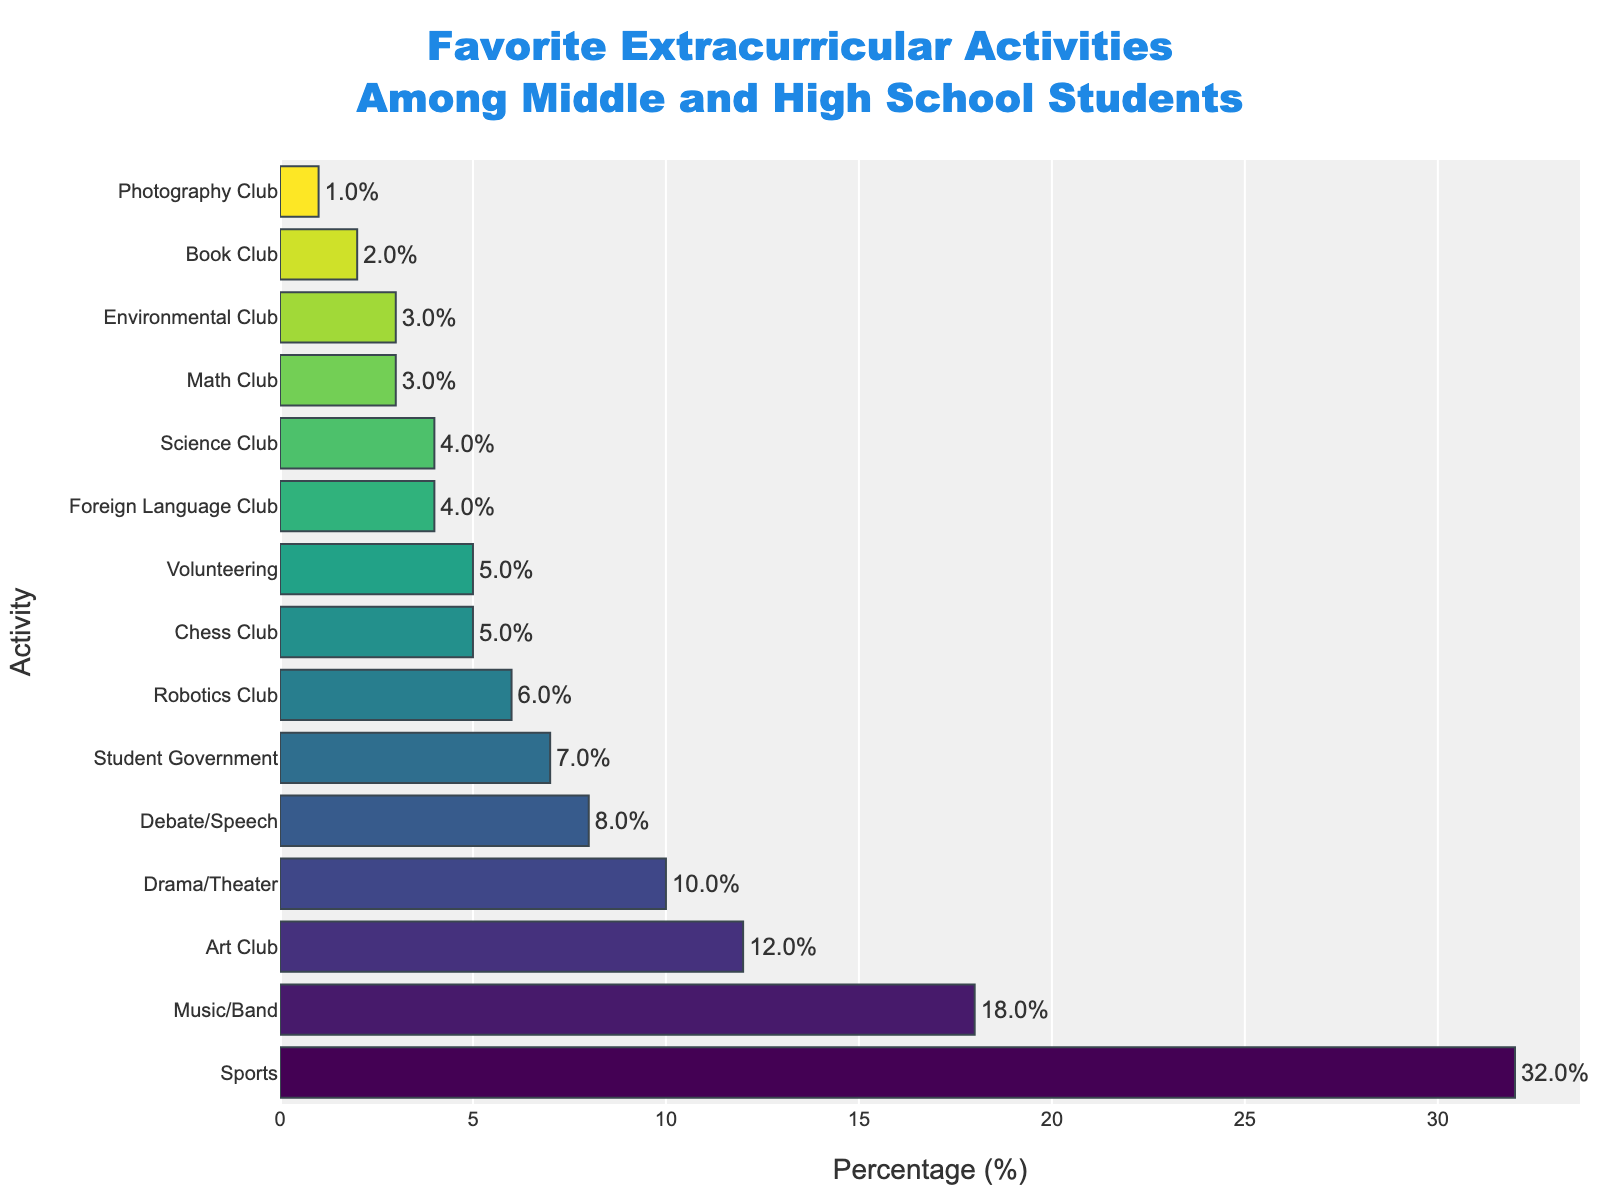what is the most popular extracurricular activity? The most popular extracurricular activity is the one with the highest percentage in the bar chart. In this case, "Sports" has the highest percentage at 32%.
Answer: Sports How does the percentage of students in Music/Band compare to those in Drama/Theater? Compare the percentages for Music/Band (18%) and Drama/Theater (10%). The difference can be found by subtracting the smaller percentage from the larger one: 18% - 10% = 8%.
Answer: Music/Band is 8% higher How many activities have a percentage greater than or equal to 10%? Count the number of activities with percentages 10% or more. From the chart, these activities are: Sports (32%), Music/Band (18%), Art Club (12%), and Drama/Theater (10%). That’s 4 activities in total.
Answer: 4 activities What is the percentage difference between the most and the least popular activities? The most popular activity is Sports (32%) and the least popular is Photography Club (1%). Subtract the percentage of the least popular from the most popular: 32% - 1% = 31%.
Answer: 31% What percentage of students are involved in academic-focused clubs (Robotics Club, Science Club, Math Club)? Add the percentages of Robotics Club (6%), Science Club (4%), and Math Club (3%). The total is 6% + 4% + 3% = 13%.
Answer: 13% Which non-sports activity has the closest percentage to Student Government? Student Government has a percentage of 7%. Among other activities, Volunteering and Chess Club both have percentages of 5% which are closest to 7%.
Answer: Volunteering and Chess Club If the combined percentage of Debate/Speech and Environmental Club was recalculated, what would it be? Add the percentages of Debate/Speech (8%) and Environmental Club (3%). The total is 8% + 3% = 11%.
Answer: 11% Which activities have an equal percentage of students participating? The activities with equal participation are Chess Club and Volunteering, both have a percentage of 5%. Also, Foreign Language Club and Science Club both have a percentage of 4%.
Answer: Chess Club and Volunteering, Foreign Language Club and Science Club If Photography Club's percentage doubled next year, what would it be? Double the current percentage of Photography Club (1%) to get the new value: 1% * 2 = 2%.
Answer: 2% How much higher is the participation in Sports compared to Math Club? Subtract the percentage of Math Club (3%) from the percentage of Sports (32%): 32% - 3% = 29%.
Answer: 29% higher 